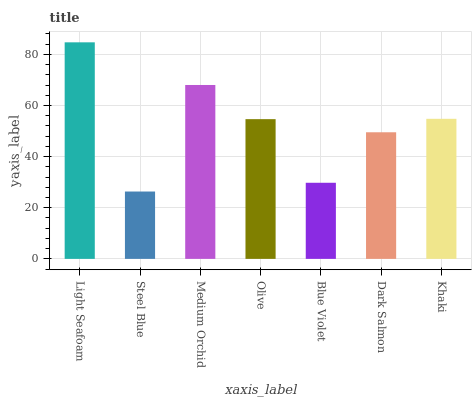Is Steel Blue the minimum?
Answer yes or no. Yes. Is Light Seafoam the maximum?
Answer yes or no. Yes. Is Medium Orchid the minimum?
Answer yes or no. No. Is Medium Orchid the maximum?
Answer yes or no. No. Is Medium Orchid greater than Steel Blue?
Answer yes or no. Yes. Is Steel Blue less than Medium Orchid?
Answer yes or no. Yes. Is Steel Blue greater than Medium Orchid?
Answer yes or no. No. Is Medium Orchid less than Steel Blue?
Answer yes or no. No. Is Olive the high median?
Answer yes or no. Yes. Is Olive the low median?
Answer yes or no. Yes. Is Medium Orchid the high median?
Answer yes or no. No. Is Steel Blue the low median?
Answer yes or no. No. 